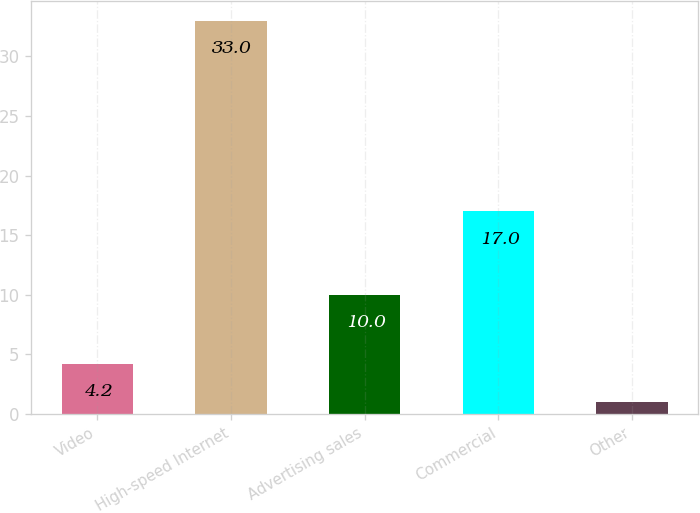Convert chart to OTSL. <chart><loc_0><loc_0><loc_500><loc_500><bar_chart><fcel>Video<fcel>High-speed Internet<fcel>Advertising sales<fcel>Commercial<fcel>Other<nl><fcel>4.2<fcel>33<fcel>10<fcel>17<fcel>1<nl></chart> 